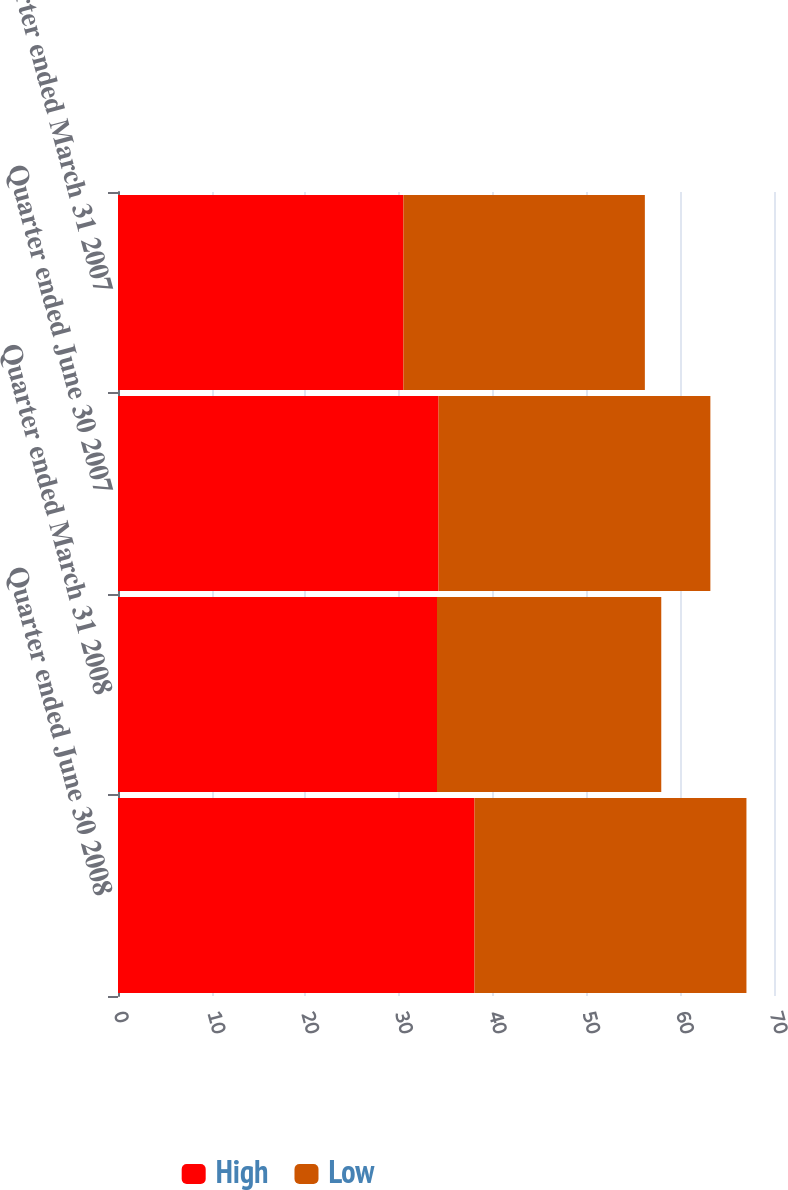<chart> <loc_0><loc_0><loc_500><loc_500><stacked_bar_chart><ecel><fcel>Quarter ended June 30 2008<fcel>Quarter ended March 31 2008<fcel>Quarter ended June 30 2007<fcel>Quarter ended March 31 2007<nl><fcel>High<fcel>38.04<fcel>34.04<fcel>34.21<fcel>30.46<nl><fcel>Low<fcel>29.02<fcel>23.93<fcel>29<fcel>25.76<nl></chart> 